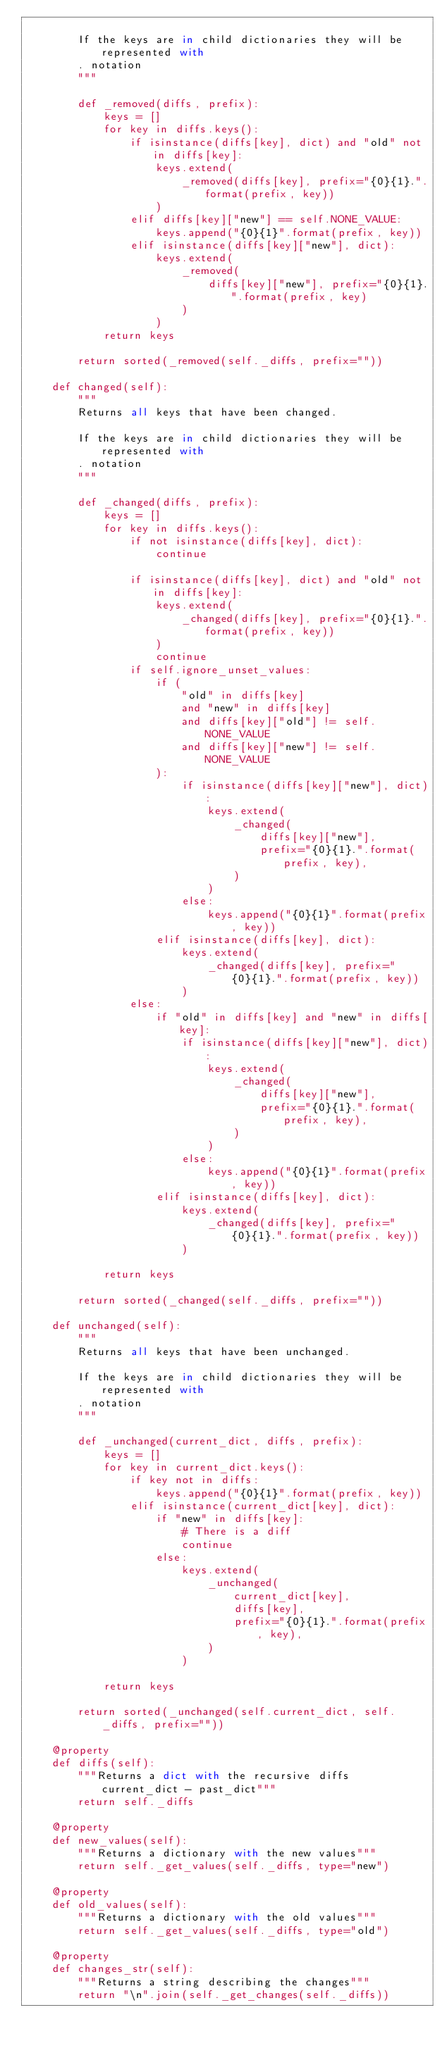Convert code to text. <code><loc_0><loc_0><loc_500><loc_500><_Python_>
        If the keys are in child dictionaries they will be represented with
        . notation
        """

        def _removed(diffs, prefix):
            keys = []
            for key in diffs.keys():
                if isinstance(diffs[key], dict) and "old" not in diffs[key]:
                    keys.extend(
                        _removed(diffs[key], prefix="{0}{1}.".format(prefix, key))
                    )
                elif diffs[key]["new"] == self.NONE_VALUE:
                    keys.append("{0}{1}".format(prefix, key))
                elif isinstance(diffs[key]["new"], dict):
                    keys.extend(
                        _removed(
                            diffs[key]["new"], prefix="{0}{1}.".format(prefix, key)
                        )
                    )
            return keys

        return sorted(_removed(self._diffs, prefix=""))

    def changed(self):
        """
        Returns all keys that have been changed.

        If the keys are in child dictionaries they will be represented with
        . notation
        """

        def _changed(diffs, prefix):
            keys = []
            for key in diffs.keys():
                if not isinstance(diffs[key], dict):
                    continue

                if isinstance(diffs[key], dict) and "old" not in diffs[key]:
                    keys.extend(
                        _changed(diffs[key], prefix="{0}{1}.".format(prefix, key))
                    )
                    continue
                if self.ignore_unset_values:
                    if (
                        "old" in diffs[key]
                        and "new" in diffs[key]
                        and diffs[key]["old"] != self.NONE_VALUE
                        and diffs[key]["new"] != self.NONE_VALUE
                    ):
                        if isinstance(diffs[key]["new"], dict):
                            keys.extend(
                                _changed(
                                    diffs[key]["new"],
                                    prefix="{0}{1}.".format(prefix, key),
                                )
                            )
                        else:
                            keys.append("{0}{1}".format(prefix, key))
                    elif isinstance(diffs[key], dict):
                        keys.extend(
                            _changed(diffs[key], prefix="{0}{1}.".format(prefix, key))
                        )
                else:
                    if "old" in diffs[key] and "new" in diffs[key]:
                        if isinstance(diffs[key]["new"], dict):
                            keys.extend(
                                _changed(
                                    diffs[key]["new"],
                                    prefix="{0}{1}.".format(prefix, key),
                                )
                            )
                        else:
                            keys.append("{0}{1}".format(prefix, key))
                    elif isinstance(diffs[key], dict):
                        keys.extend(
                            _changed(diffs[key], prefix="{0}{1}.".format(prefix, key))
                        )

            return keys

        return sorted(_changed(self._diffs, prefix=""))

    def unchanged(self):
        """
        Returns all keys that have been unchanged.

        If the keys are in child dictionaries they will be represented with
        . notation
        """

        def _unchanged(current_dict, diffs, prefix):
            keys = []
            for key in current_dict.keys():
                if key not in diffs:
                    keys.append("{0}{1}".format(prefix, key))
                elif isinstance(current_dict[key], dict):
                    if "new" in diffs[key]:
                        # There is a diff
                        continue
                    else:
                        keys.extend(
                            _unchanged(
                                current_dict[key],
                                diffs[key],
                                prefix="{0}{1}.".format(prefix, key),
                            )
                        )

            return keys

        return sorted(_unchanged(self.current_dict, self._diffs, prefix=""))

    @property
    def diffs(self):
        """Returns a dict with the recursive diffs current_dict - past_dict"""
        return self._diffs

    @property
    def new_values(self):
        """Returns a dictionary with the new values"""
        return self._get_values(self._diffs, type="new")

    @property
    def old_values(self):
        """Returns a dictionary with the old values"""
        return self._get_values(self._diffs, type="old")

    @property
    def changes_str(self):
        """Returns a string describing the changes"""
        return "\n".join(self._get_changes(self._diffs))
</code> 